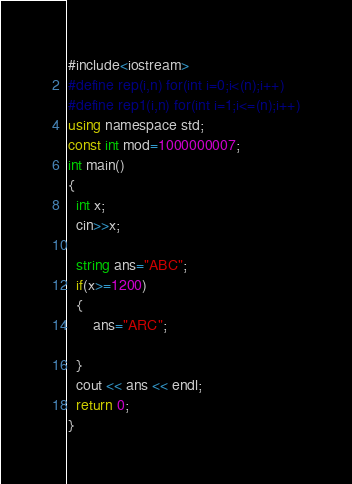<code> <loc_0><loc_0><loc_500><loc_500><_C#_>#include<iostream>
#define rep(i,n) for(int i=0;i<(n);i++)
#define rep1(i,n) for(int i=1;i<=(n);i++)
using namespace std;
const int mod=1000000007;
int main()
{
  int x;
  cin>>x;
  
  string ans="ABC";
  if(x>=1200)
  {
	  ans="ARC";
	  
  }
  cout << ans << endl;
  return 0;
}
</code> 